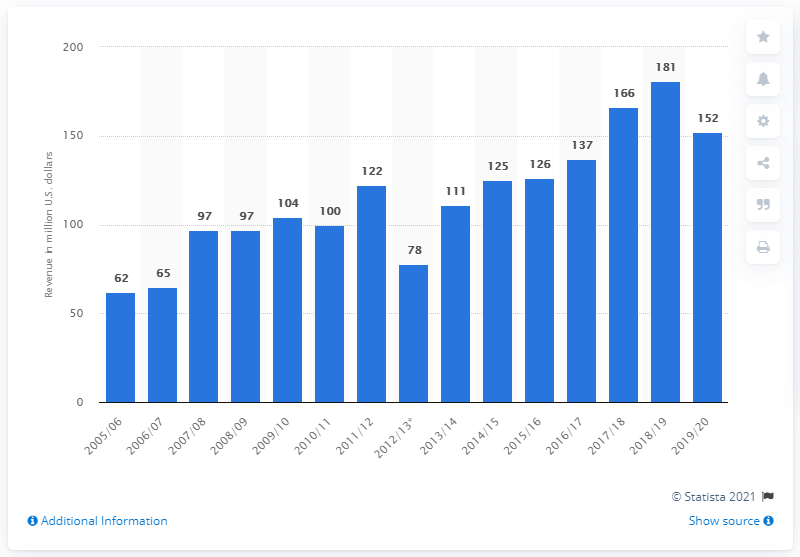Specify some key components in this picture. The revenue of the New Jersey Devils in the 2019/20 season was 152 million dollars. 